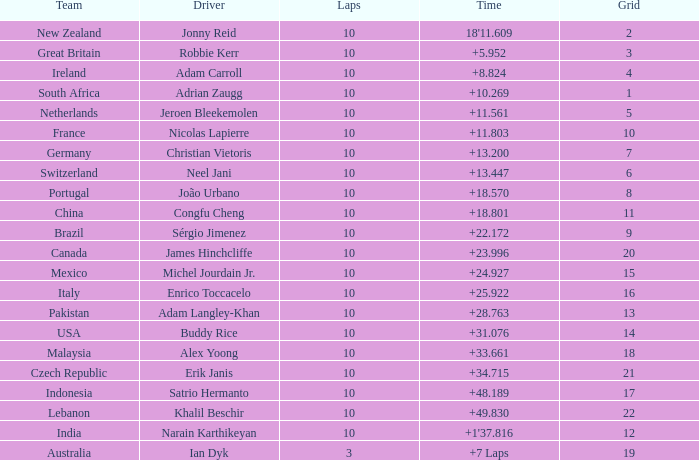Could you parse the entire table as a dict? {'header': ['Team', 'Driver', 'Laps', 'Time', 'Grid'], 'rows': [['New Zealand', 'Jonny Reid', '10', "18'11.609", '2'], ['Great Britain', 'Robbie Kerr', '10', '+5.952', '3'], ['Ireland', 'Adam Carroll', '10', '+8.824', '4'], ['South Africa', 'Adrian Zaugg', '10', '+10.269', '1'], ['Netherlands', 'Jeroen Bleekemolen', '10', '+11.561', '5'], ['France', 'Nicolas Lapierre', '10', '+11.803', '10'], ['Germany', 'Christian Vietoris', '10', '+13.200', '7'], ['Switzerland', 'Neel Jani', '10', '+13.447', '6'], ['Portugal', 'João Urbano', '10', '+18.570', '8'], ['China', 'Congfu Cheng', '10', '+18.801', '11'], ['Brazil', 'Sérgio Jimenez', '10', '+22.172', '9'], ['Canada', 'James Hinchcliffe', '10', '+23.996', '20'], ['Mexico', 'Michel Jourdain Jr.', '10', '+24.927', '15'], ['Italy', 'Enrico Toccacelo', '10', '+25.922', '16'], ['Pakistan', 'Adam Langley-Khan', '10', '+28.763', '13'], ['USA', 'Buddy Rice', '10', '+31.076', '14'], ['Malaysia', 'Alex Yoong', '10', '+33.661', '18'], ['Czech Republic', 'Erik Janis', '10', '+34.715', '21'], ['Indonesia', 'Satrio Hermanto', '10', '+48.189', '17'], ['Lebanon', 'Khalil Beschir', '10', '+49.830', '22'], ['India', 'Narain Karthikeyan', '10', "+1'37.816", '12'], ['Australia', 'Ian Dyk', '3', '+7 Laps', '19']]} What team had 10 Labs and the Driver was Alex Yoong? Malaysia. 